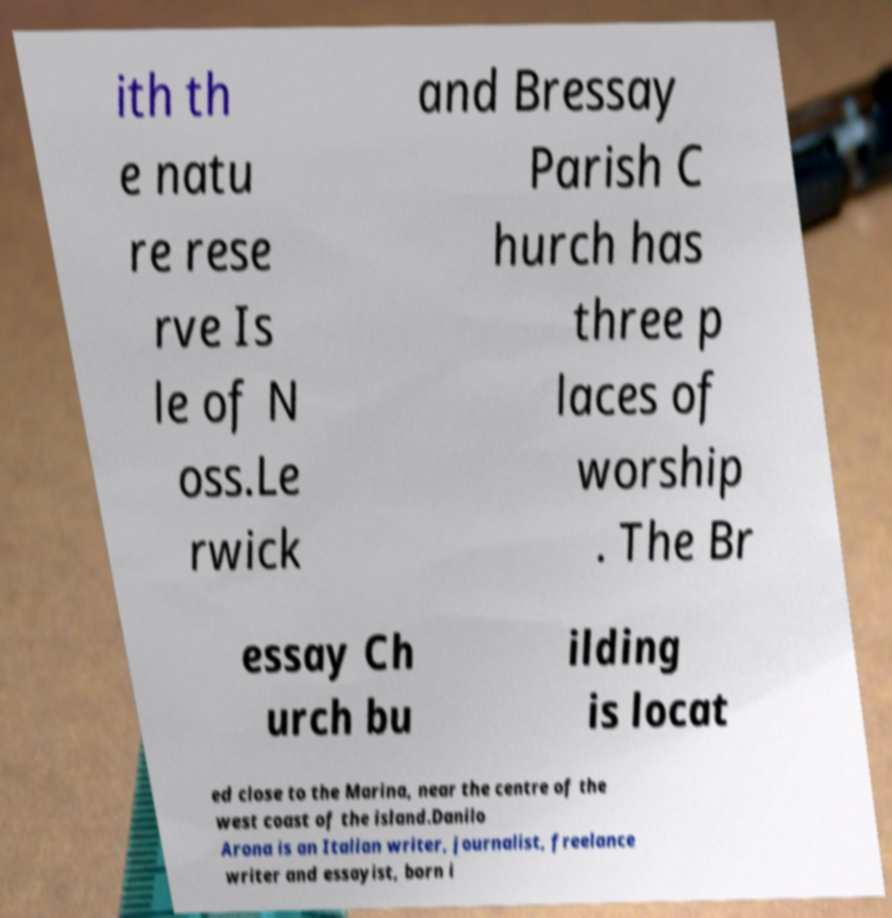Can you accurately transcribe the text from the provided image for me? ith th e natu re rese rve Is le of N oss.Le rwick and Bressay Parish C hurch has three p laces of worship . The Br essay Ch urch bu ilding is locat ed close to the Marina, near the centre of the west coast of the island.Danilo Arona is an Italian writer, journalist, freelance writer and essayist, born i 